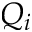<formula> <loc_0><loc_0><loc_500><loc_500>Q _ { i }</formula> 